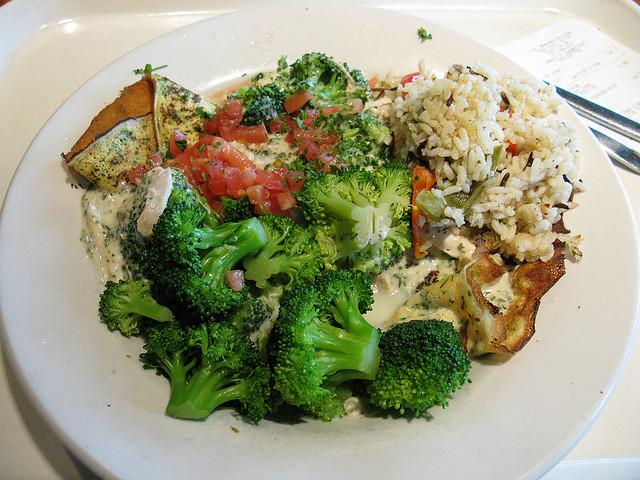Is the plate of food good?
Concise answer only. Yes. What kind of dinner is in the plate?
Be succinct. Healthy. Is this a dish that small children would like to eat?
Short answer required. No. Who took this picture?
Quick response, please. Person. What type of salad is on the plate?
Short answer required. Vegetable. What are the green objects?
Give a very brief answer. Broccoli. 